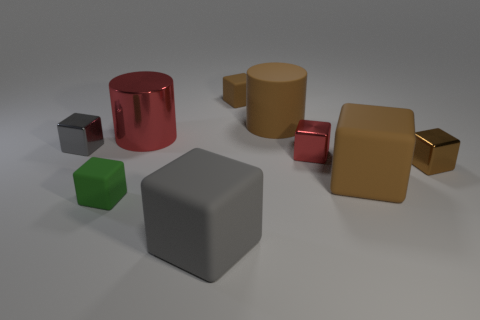Which object stands out the most, and why? The glossy red cylinder stands out prominently due to its vibrant color and reflective surface, which contrasts with the more muted tones and matte finishes of the other objects in the scene. How does the lighting affect the appearance of the objects? The soft, diffuse lighting in the image casts gentle shadows and highlights the textures and material properties of the objects. It enhances the metallic sheen of the gold and red objects and emphasizes the difference between shiny and matte surfaces. 